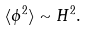Convert formula to latex. <formula><loc_0><loc_0><loc_500><loc_500>\langle \phi ^ { 2 } \rangle \sim H ^ { 2 } .</formula> 